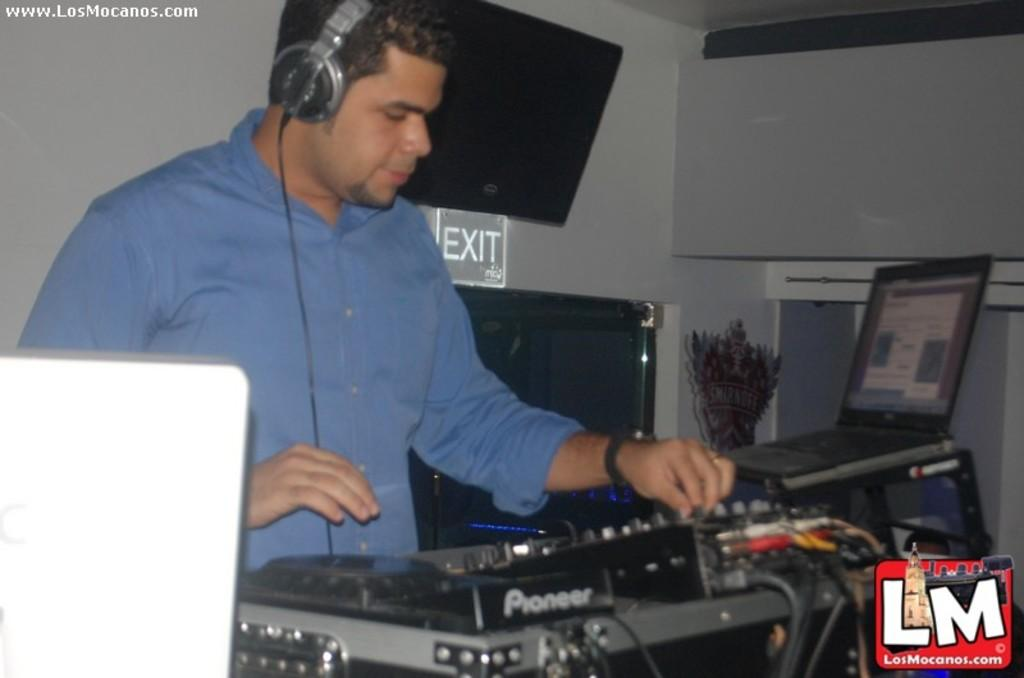<image>
Summarize the visual content of the image. A disc jockey playing music part of Los Mocanos. 